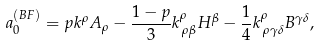Convert formula to latex. <formula><loc_0><loc_0><loc_500><loc_500>a _ { 0 } ^ { ( B F ) } = p k ^ { \rho } A _ { \rho } - \frac { 1 - p } { 3 } k _ { \, \rho \beta } ^ { \rho } H ^ { \beta } - \frac { 1 } { 4 } k _ { \, \rho \gamma \delta } ^ { \rho } B ^ { \gamma \delta } ,</formula> 